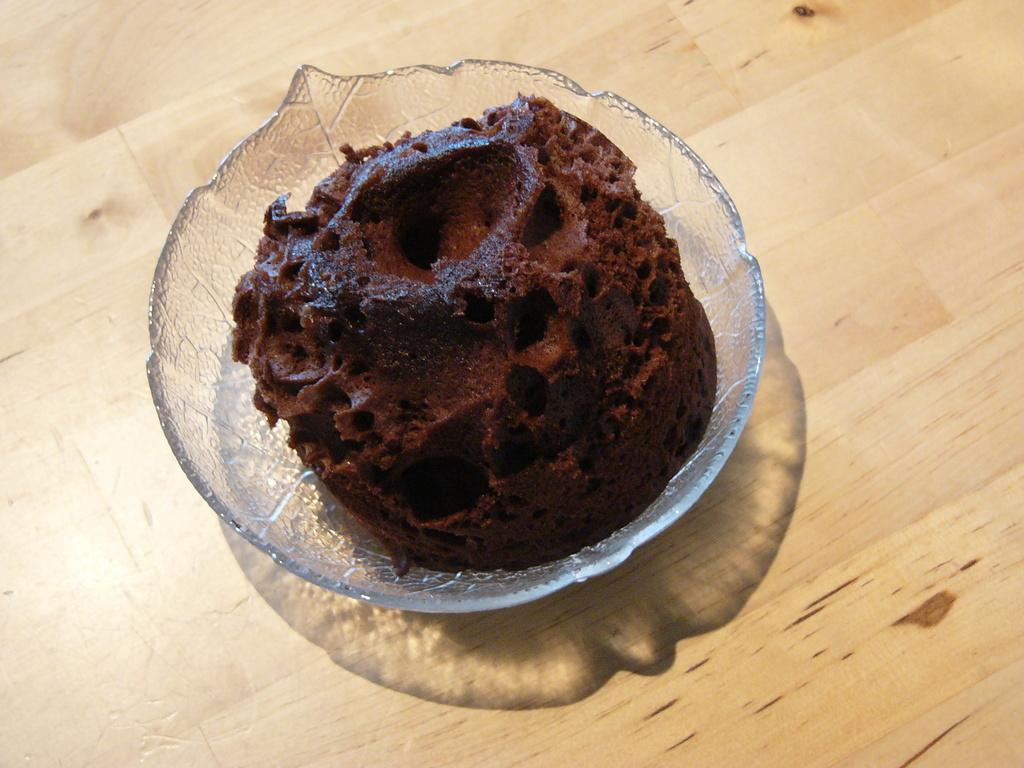What type of food item is visible in the image? The food item in the image is not specified, but it is present. How is the food item contained in the image? The food item is in a glass bowl. What is the surface beneath the glass bowl? The glass bowl is on a wooden surface. What color is the silver stocking that the person is wearing in the image? There is no person or silver stocking present in the image. 